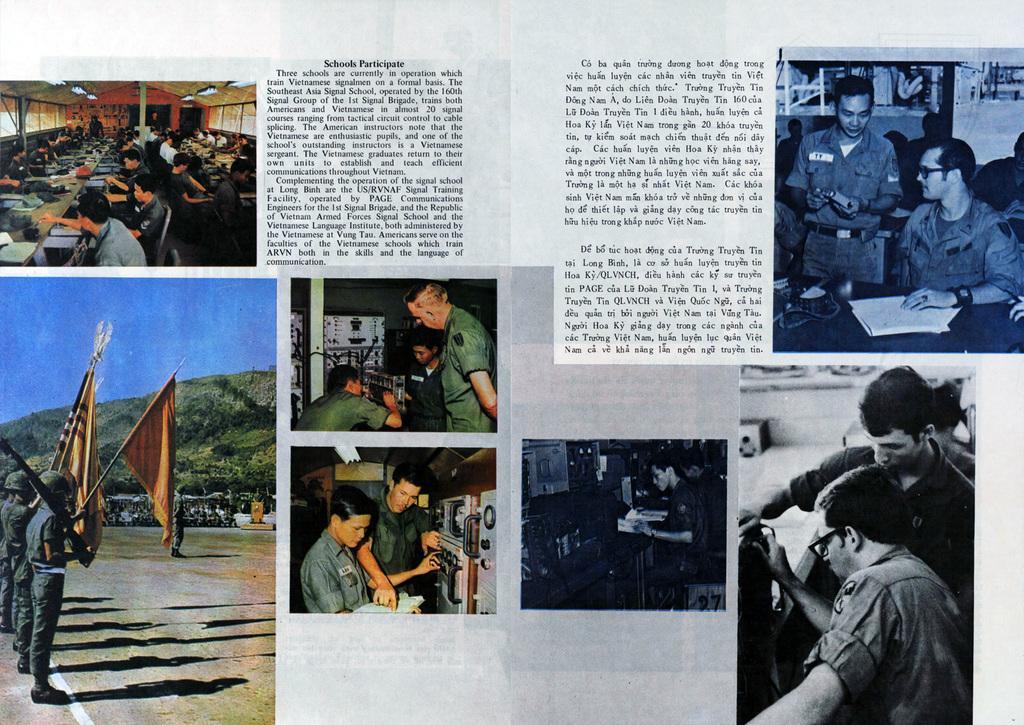In one or two sentences, can you explain what this image depicts? In this image we can see a paper. There are many photos on the paper. There is some description of the photos in the image. There are many people, objects, a sky etc., in the image. 